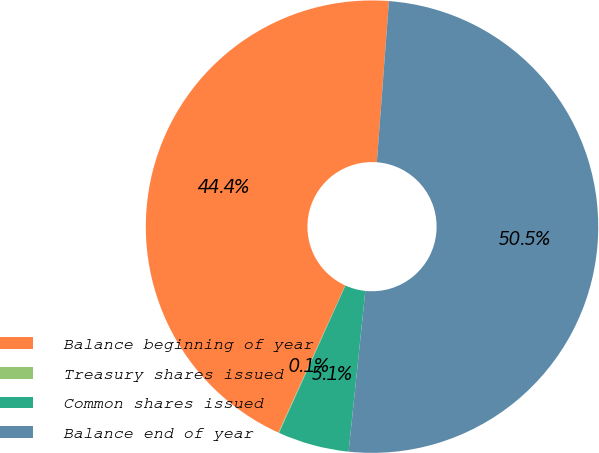<chart> <loc_0><loc_0><loc_500><loc_500><pie_chart><fcel>Balance beginning of year<fcel>Treasury shares issued<fcel>Common shares issued<fcel>Balance end of year<nl><fcel>44.4%<fcel>0.05%<fcel>5.09%<fcel>50.46%<nl></chart> 